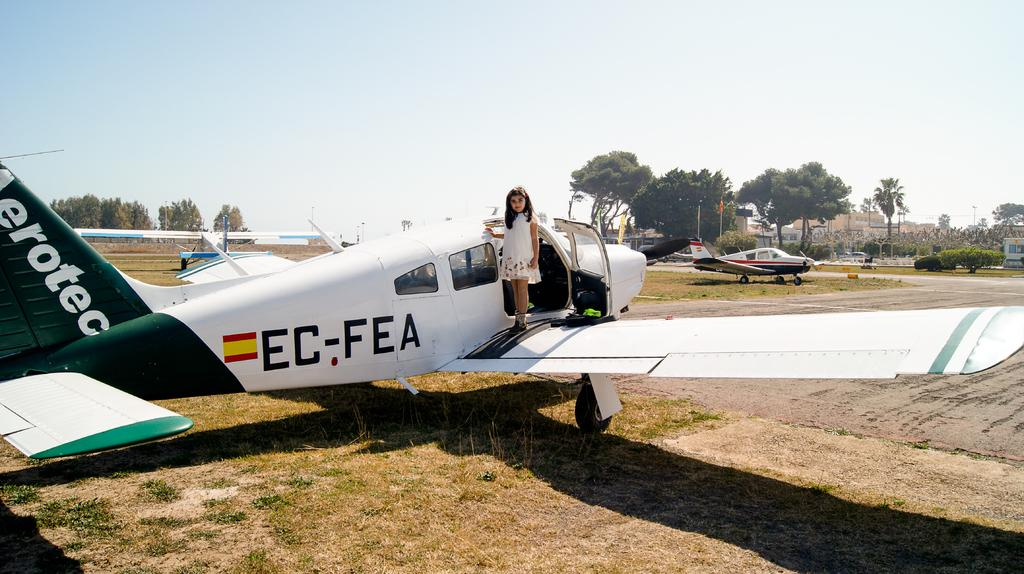What is the main subject in the foreground of the image? There is a girl standing on an airplane in the foreground of the image. Where is the airplane located? The airplane is on the grass. What can be seen in the background of the image? There are airplanes, flags, plants, trees, and the sky visible in the background of the image. What type of baseball game is being played in the background of the image? There is no baseball game present in the image; it features a girl standing on an airplane and various elements in the background. How many times does the girl shake hands with the pilot in the image? There is no indication in the image that the girl is shaking hands with a pilot or anyone else. 